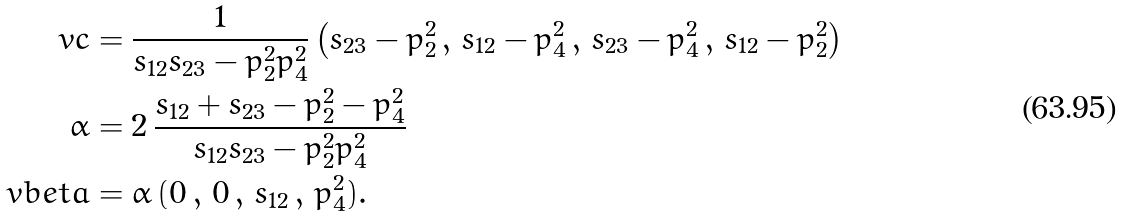Convert formula to latex. <formula><loc_0><loc_0><loc_500><loc_500>\ v c & = \frac { 1 } { s _ { 1 2 } s _ { 2 3 } - p _ { 2 } ^ { 2 } p _ { 4 } ^ { 2 } } \left ( s _ { 2 3 } - p _ { 2 } ^ { 2 } \, , \, s _ { 1 2 } - p _ { 4 } ^ { 2 } \, , \, s _ { 2 3 } - p _ { 4 } ^ { 2 } \, , \, s _ { 1 2 } - p _ { 2 } ^ { 2 } \right ) \\ \alpha & = 2 \, \frac { s _ { 1 2 } + s _ { 2 3 } - p _ { 2 } ^ { 2 } - p _ { 4 } ^ { 2 } } { s _ { 1 2 } s _ { 2 3 } - p _ { 2 } ^ { 2 } p _ { 4 } ^ { 2 } } \\ \ v b e t a & = \alpha \, ( 0 \, , \, 0 \, , \, s _ { 1 2 } \, , \, p _ { 4 } ^ { 2 } ) .</formula> 